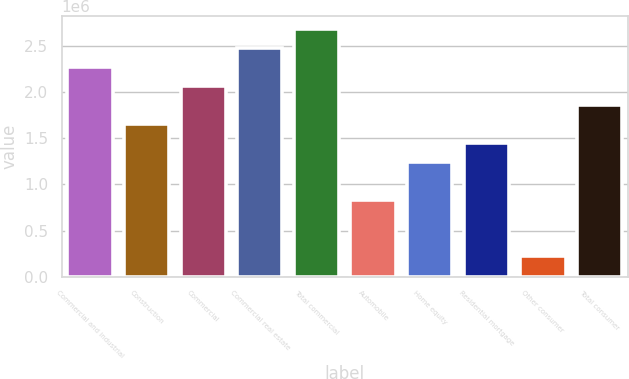Convert chart to OTSL. <chart><loc_0><loc_0><loc_500><loc_500><bar_chart><fcel>Commercial and industrial<fcel>Construction<fcel>Commercial<fcel>Commercial real estate<fcel>Total commercial<fcel>Automobile<fcel>Home equity<fcel>Residential mortgage<fcel>Other consumer<fcel>Total consumer<nl><fcel>2.27553e+06<fcel>1.65874e+06<fcel>2.06993e+06<fcel>2.48113e+06<fcel>2.68672e+06<fcel>836343<fcel>1.24754e+06<fcel>1.45314e+06<fcel>219549<fcel>1.86433e+06<nl></chart> 